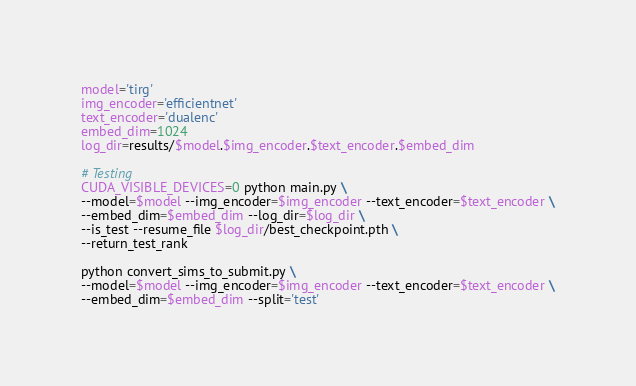<code> <loc_0><loc_0><loc_500><loc_500><_Bash_>model='tirg'
img_encoder='efficientnet'
text_encoder='dualenc'
embed_dim=1024
log_dir=results/$model.$img_encoder.$text_encoder.$embed_dim

# Testing 
CUDA_VISIBLE_DEVICES=0 python main.py \
--model=$model --img_encoder=$img_encoder --text_encoder=$text_encoder \
--embed_dim=$embed_dim --log_dir=$log_dir \
--is_test --resume_file $log_dir/best_checkpoint.pth \
--return_test_rank

python convert_sims_to_submit.py \
--model=$model --img_encoder=$img_encoder --text_encoder=$text_encoder \
--embed_dim=$embed_dim --split='test'</code> 